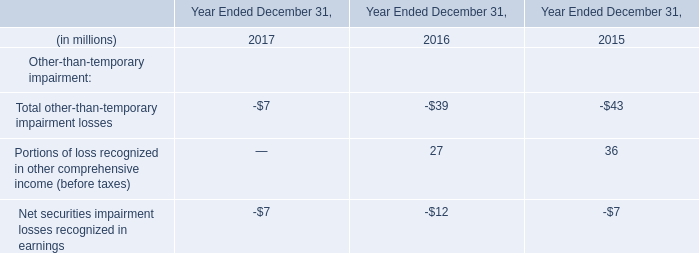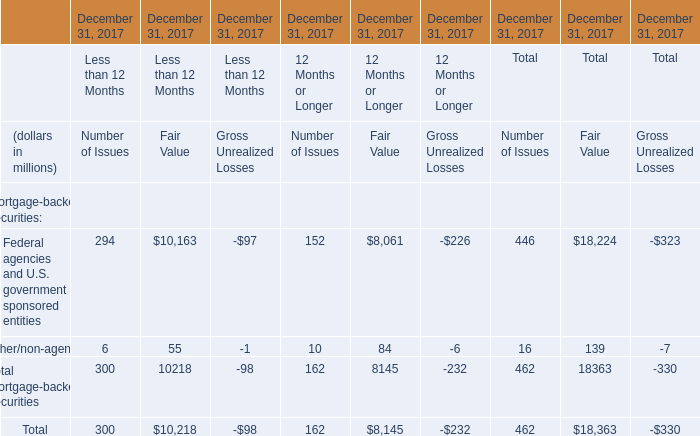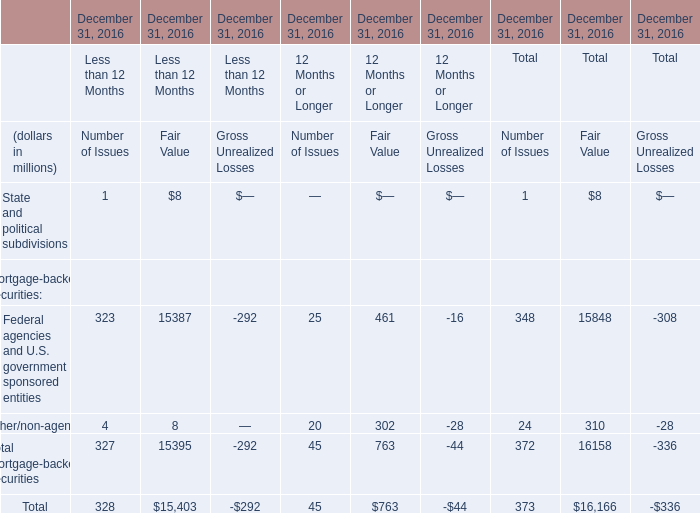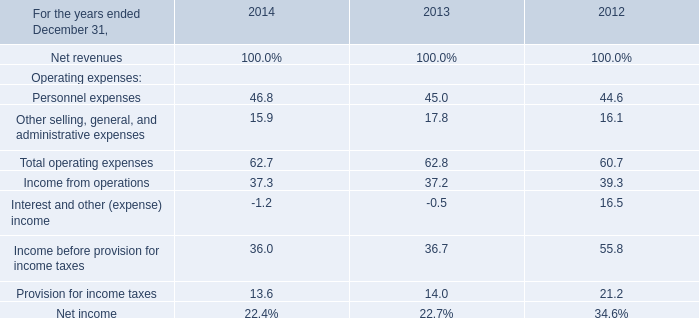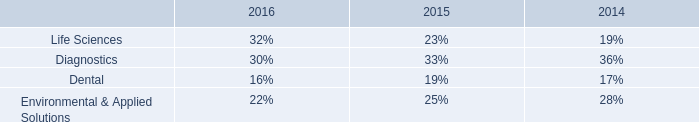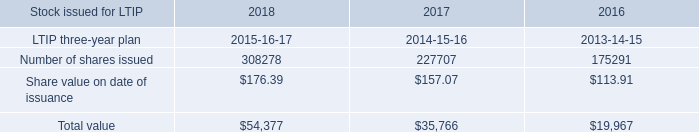What is the percentage of Other/non-agency in relation to the total for Number of Issues? 
Computations: (24 / 373)
Answer: 0.06434. 